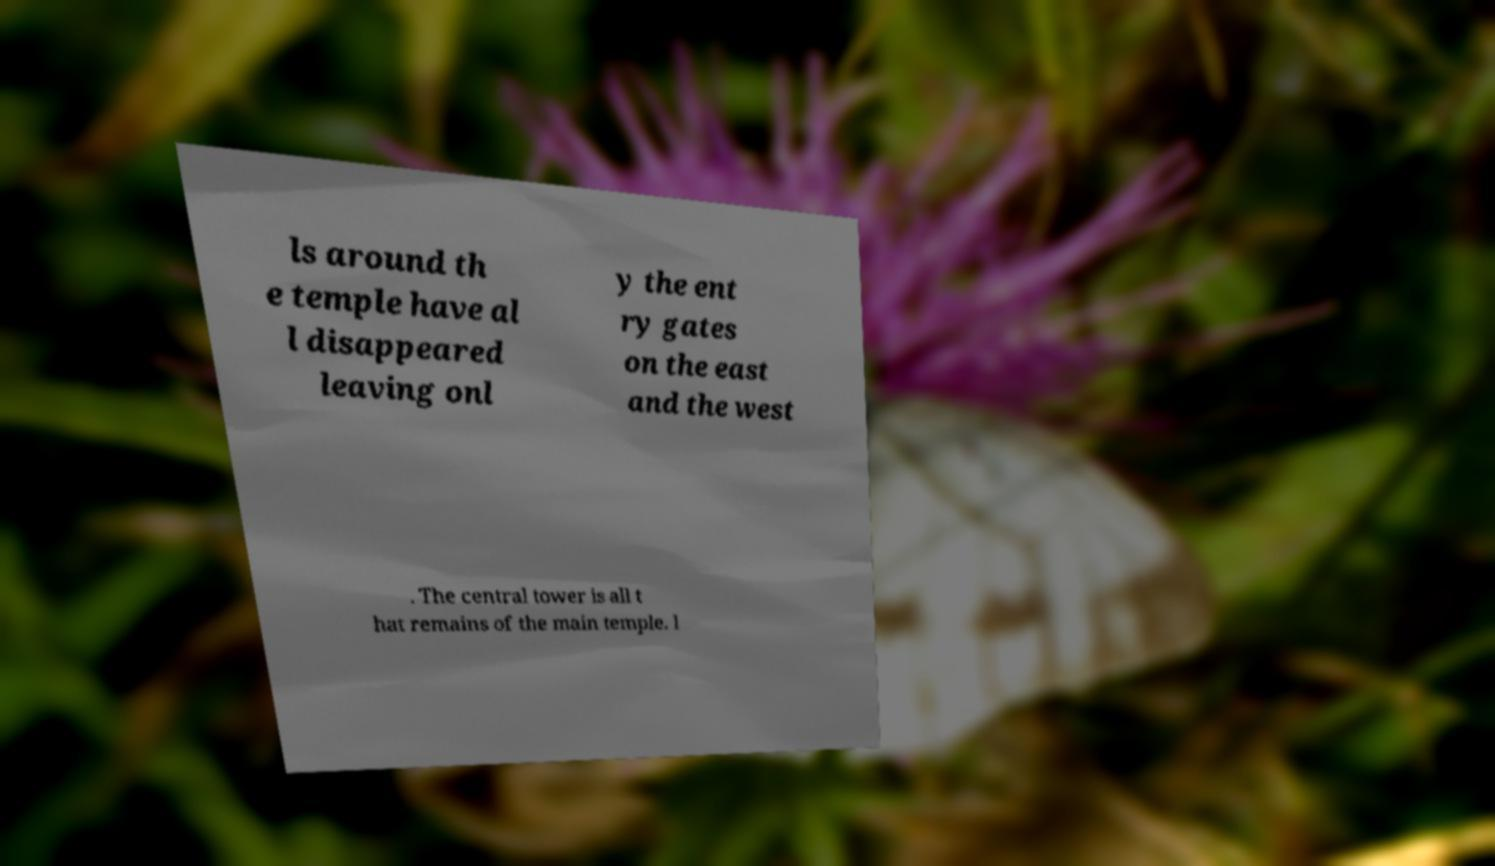Could you extract and type out the text from this image? ls around th e temple have al l disappeared leaving onl y the ent ry gates on the east and the west . The central tower is all t hat remains of the main temple. I 